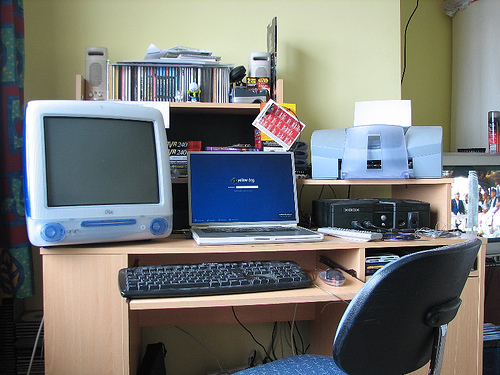<image>
Can you confirm if the keyboard is in front of the chair? Yes. The keyboard is positioned in front of the chair, appearing closer to the camera viewpoint. Where is the speaker in relation to the imac? Is it above the imac? No. The speaker is not positioned above the imac. The vertical arrangement shows a different relationship. 